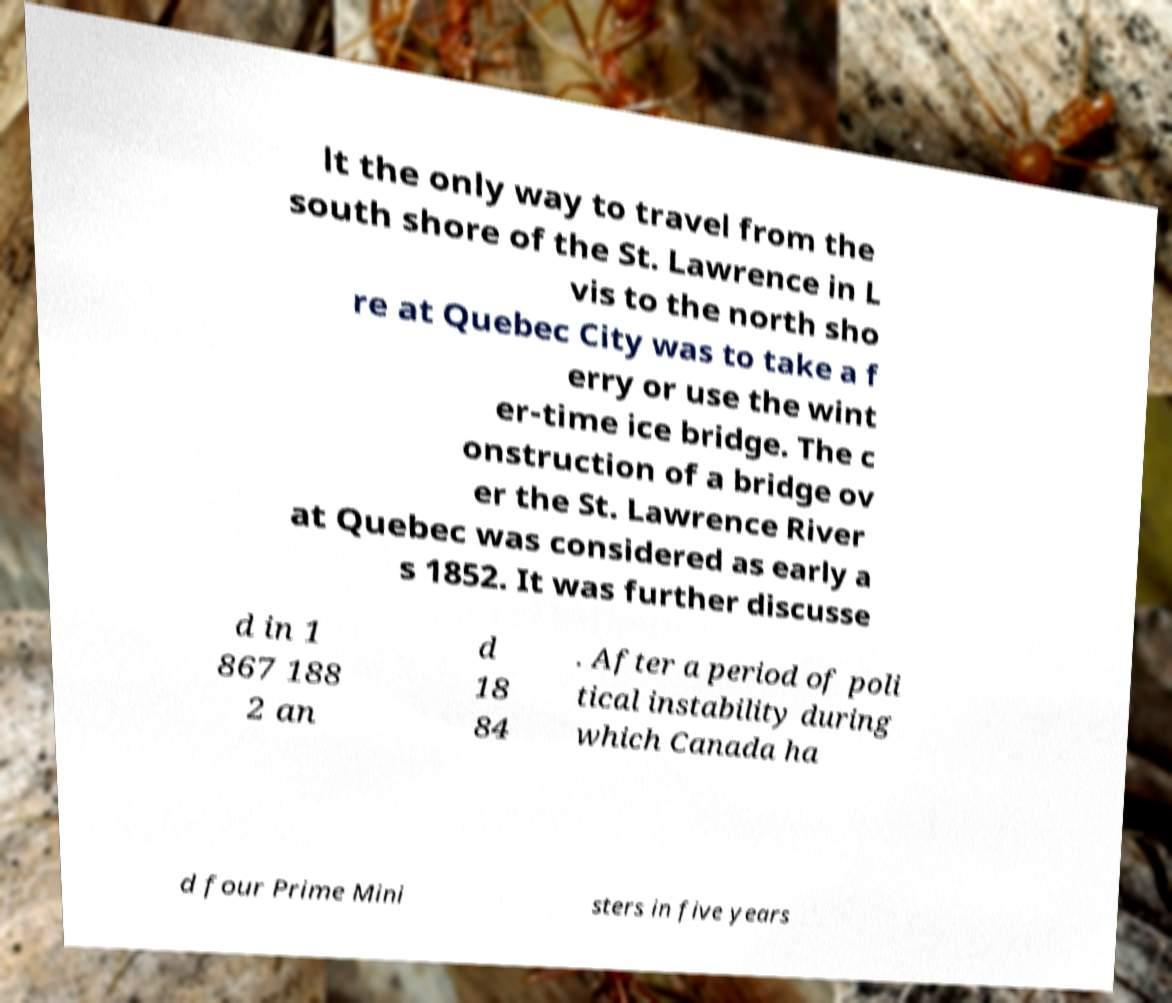There's text embedded in this image that I need extracted. Can you transcribe it verbatim? lt the only way to travel from the south shore of the St. Lawrence in L vis to the north sho re at Quebec City was to take a f erry or use the wint er-time ice bridge. The c onstruction of a bridge ov er the St. Lawrence River at Quebec was considered as early a s 1852. It was further discusse d in 1 867 188 2 an d 18 84 . After a period of poli tical instability during which Canada ha d four Prime Mini sters in five years 